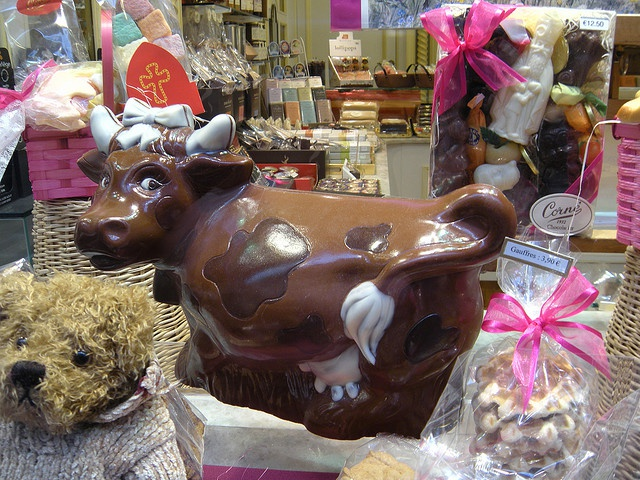Describe the objects in this image and their specific colors. I can see cow in darkgray, black, gray, and maroon tones and teddy bear in darkgray, tan, gray, and black tones in this image. 